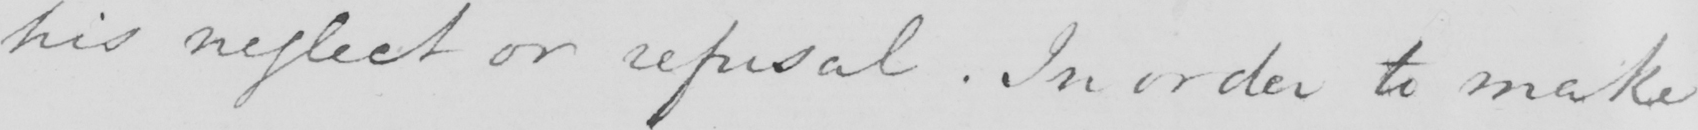What text is written in this handwritten line? his neglect or refusal . In order to make 